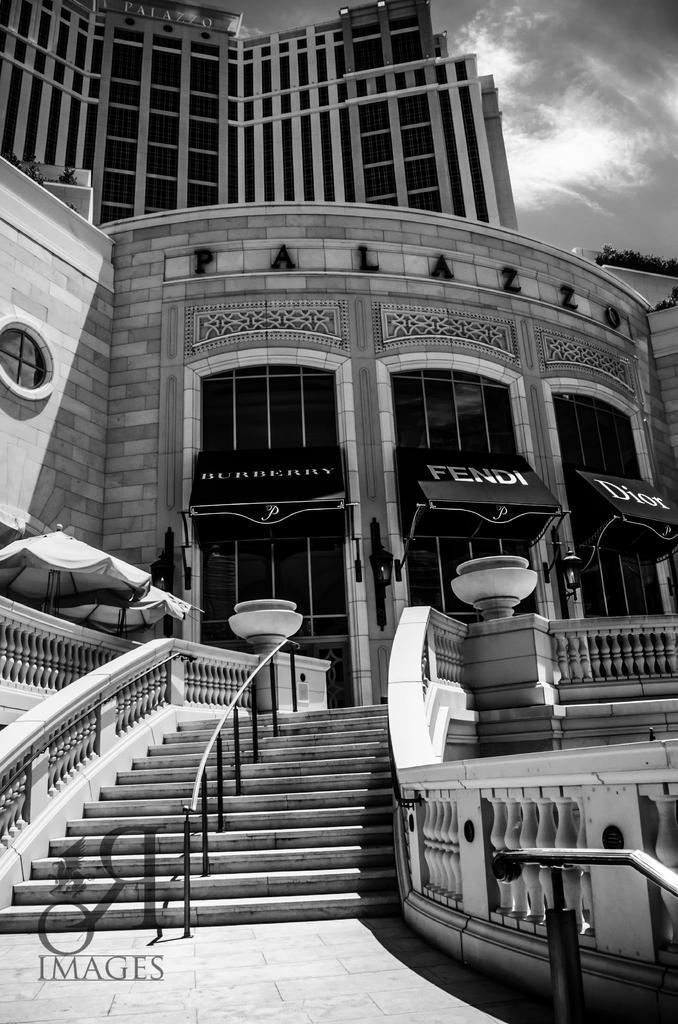Please provide a concise description of this image. In this picture we can see a building and some objects and we can see sky in the background, in the bottom left we can see some text. 